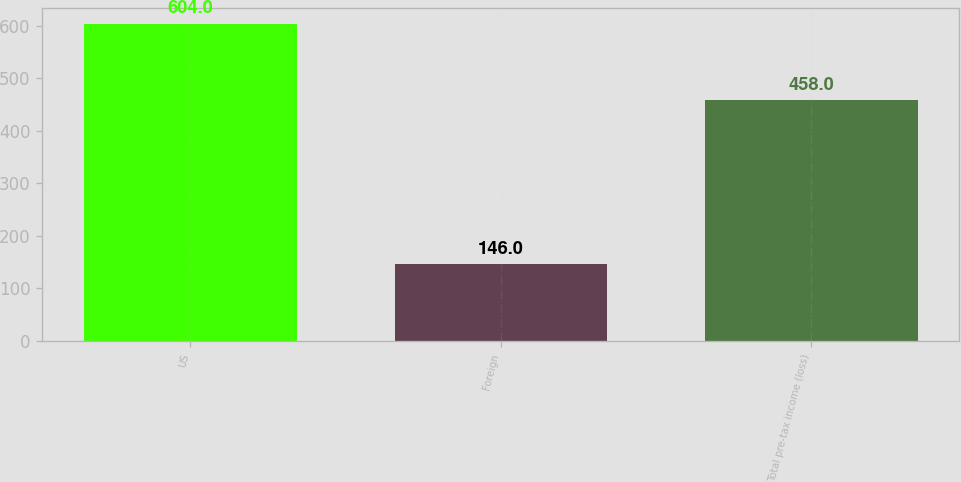Convert chart. <chart><loc_0><loc_0><loc_500><loc_500><bar_chart><fcel>US<fcel>Foreign<fcel>Total pre-tax income (loss)<nl><fcel>604<fcel>146<fcel>458<nl></chart> 